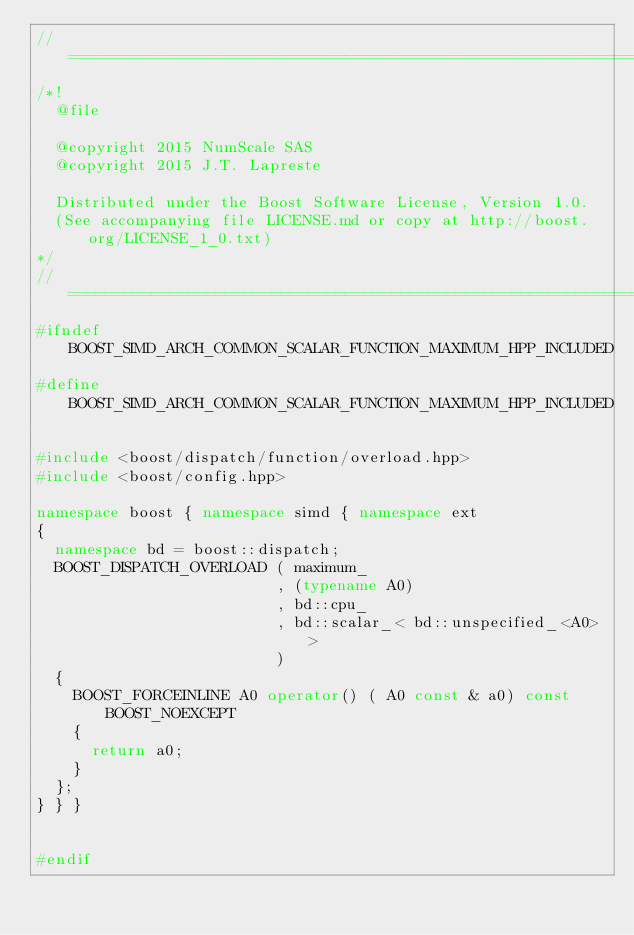<code> <loc_0><loc_0><loc_500><loc_500><_C++_>//==================================================================================================
/*!
  @file

  @copyright 2015 NumScale SAS
  @copyright 2015 J.T. Lapreste

  Distributed under the Boost Software License, Version 1.0.
  (See accompanying file LICENSE.md or copy at http://boost.org/LICENSE_1_0.txt)
*/
//==================================================================================================
#ifndef BOOST_SIMD_ARCH_COMMON_SCALAR_FUNCTION_MAXIMUM_HPP_INCLUDED
#define BOOST_SIMD_ARCH_COMMON_SCALAR_FUNCTION_MAXIMUM_HPP_INCLUDED

#include <boost/dispatch/function/overload.hpp>
#include <boost/config.hpp>

namespace boost { namespace simd { namespace ext
{
  namespace bd = boost::dispatch;
  BOOST_DISPATCH_OVERLOAD ( maximum_
                          , (typename A0)
                          , bd::cpu_
                          , bd::scalar_< bd::unspecified_<A0> >
                          )
  {
    BOOST_FORCEINLINE A0 operator() ( A0 const & a0) const BOOST_NOEXCEPT
    {
      return a0;
    }
  };
} } }


#endif
</code> 